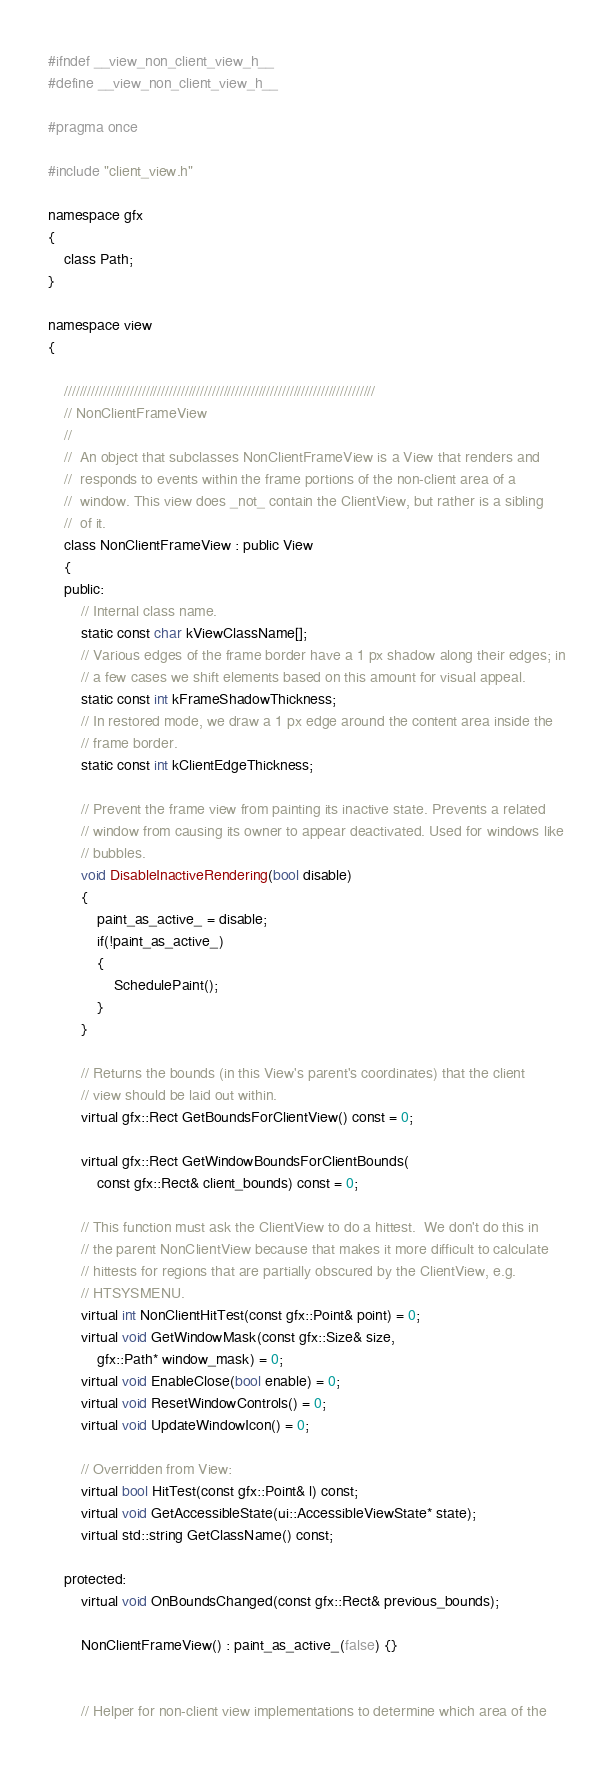<code> <loc_0><loc_0><loc_500><loc_500><_C_>
#ifndef __view_non_client_view_h__
#define __view_non_client_view_h__

#pragma once

#include "client_view.h"

namespace gfx
{
    class Path;
}

namespace view
{

    ////////////////////////////////////////////////////////////////////////////////
    // NonClientFrameView
    //
    //  An object that subclasses NonClientFrameView is a View that renders and
    //  responds to events within the frame portions of the non-client area of a
    //  window. This view does _not_ contain the ClientView, but rather is a sibling
    //  of it.
    class NonClientFrameView : public View
    {
    public:
        // Internal class name.
        static const char kViewClassName[];
        // Various edges of the frame border have a 1 px shadow along their edges; in
        // a few cases we shift elements based on this amount for visual appeal.
        static const int kFrameShadowThickness;
        // In restored mode, we draw a 1 px edge around the content area inside the
        // frame border.
        static const int kClientEdgeThickness;

        // Prevent the frame view from painting its inactive state. Prevents a related
        // window from causing its owner to appear deactivated. Used for windows like
        // bubbles.
        void DisableInactiveRendering(bool disable)
        {
            paint_as_active_ = disable;
            if(!paint_as_active_)
            {
                SchedulePaint();
            }
        }

        // Returns the bounds (in this View's parent's coordinates) that the client
        // view should be laid out within.
        virtual gfx::Rect GetBoundsForClientView() const = 0;

        virtual gfx::Rect GetWindowBoundsForClientBounds(
            const gfx::Rect& client_bounds) const = 0;

        // This function must ask the ClientView to do a hittest.  We don't do this in
        // the parent NonClientView because that makes it more difficult to calculate
        // hittests for regions that are partially obscured by the ClientView, e.g.
        // HTSYSMENU.
        virtual int NonClientHitTest(const gfx::Point& point) = 0;
        virtual void GetWindowMask(const gfx::Size& size,
            gfx::Path* window_mask) = 0;
        virtual void EnableClose(bool enable) = 0;
        virtual void ResetWindowControls() = 0;
        virtual void UpdateWindowIcon() = 0;

        // Overridden from View:
        virtual bool HitTest(const gfx::Point& l) const;
        virtual void GetAccessibleState(ui::AccessibleViewState* state);
        virtual std::string GetClassName() const;

    protected:
        virtual void OnBoundsChanged(const gfx::Rect& previous_bounds);

        NonClientFrameView() : paint_as_active_(false) {}


        // Helper for non-client view implementations to determine which area of the</code> 